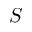Convert formula to latex. <formula><loc_0><loc_0><loc_500><loc_500>S</formula> 